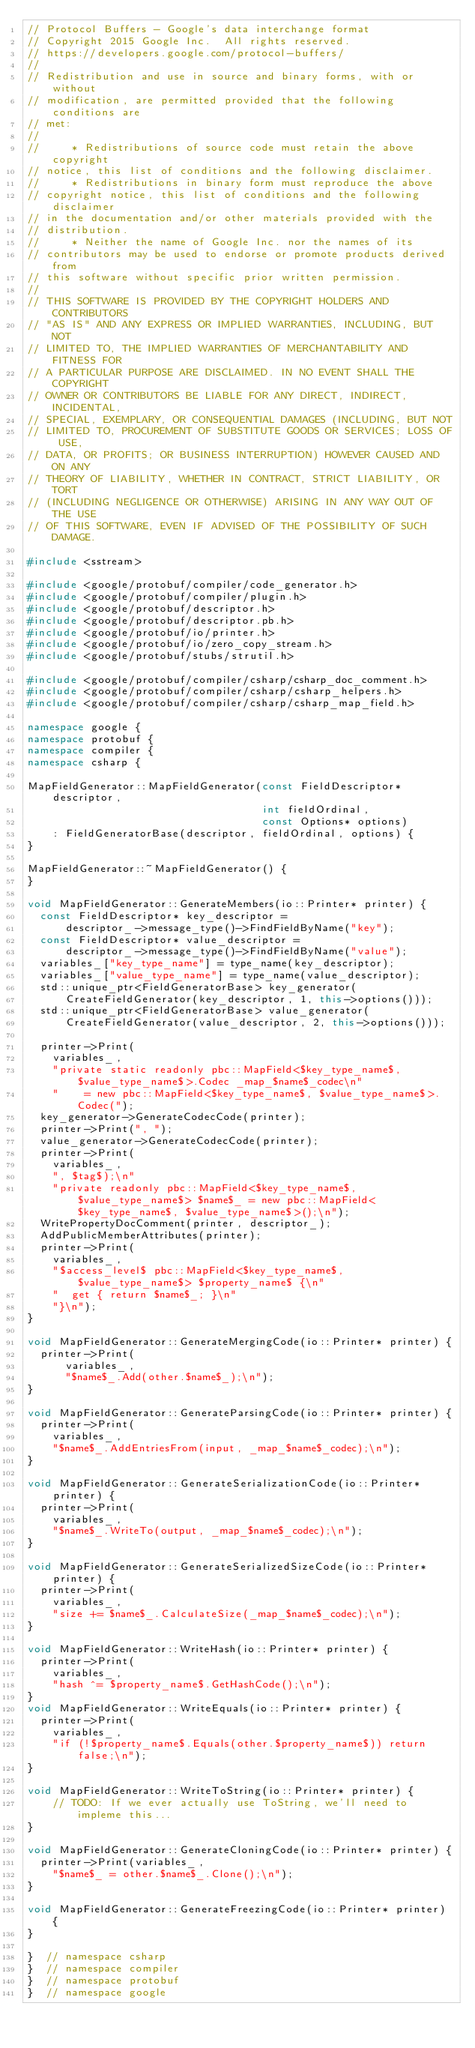Convert code to text. <code><loc_0><loc_0><loc_500><loc_500><_C++_>// Protocol Buffers - Google's data interchange format
// Copyright 2015 Google Inc.  All rights reserved.
// https://developers.google.com/protocol-buffers/
//
// Redistribution and use in source and binary forms, with or without
// modification, are permitted provided that the following conditions are
// met:
//
//     * Redistributions of source code must retain the above copyright
// notice, this list of conditions and the following disclaimer.
//     * Redistributions in binary form must reproduce the above
// copyright notice, this list of conditions and the following disclaimer
// in the documentation and/or other materials provided with the
// distribution.
//     * Neither the name of Google Inc. nor the names of its
// contributors may be used to endorse or promote products derived from
// this software without specific prior written permission.
//
// THIS SOFTWARE IS PROVIDED BY THE COPYRIGHT HOLDERS AND CONTRIBUTORS
// "AS IS" AND ANY EXPRESS OR IMPLIED WARRANTIES, INCLUDING, BUT NOT
// LIMITED TO, THE IMPLIED WARRANTIES OF MERCHANTABILITY AND FITNESS FOR
// A PARTICULAR PURPOSE ARE DISCLAIMED. IN NO EVENT SHALL THE COPYRIGHT
// OWNER OR CONTRIBUTORS BE LIABLE FOR ANY DIRECT, INDIRECT, INCIDENTAL,
// SPECIAL, EXEMPLARY, OR CONSEQUENTIAL DAMAGES (INCLUDING, BUT NOT
// LIMITED TO, PROCUREMENT OF SUBSTITUTE GOODS OR SERVICES; LOSS OF USE,
// DATA, OR PROFITS; OR BUSINESS INTERRUPTION) HOWEVER CAUSED AND ON ANY
// THEORY OF LIABILITY, WHETHER IN CONTRACT, STRICT LIABILITY, OR TORT
// (INCLUDING NEGLIGENCE OR OTHERWISE) ARISING IN ANY WAY OUT OF THE USE
// OF THIS SOFTWARE, EVEN IF ADVISED OF THE POSSIBILITY OF SUCH DAMAGE.

#include <sstream>

#include <google/protobuf/compiler/code_generator.h>
#include <google/protobuf/compiler/plugin.h>
#include <google/protobuf/descriptor.h>
#include <google/protobuf/descriptor.pb.h>
#include <google/protobuf/io/printer.h>
#include <google/protobuf/io/zero_copy_stream.h>
#include <google/protobuf/stubs/strutil.h>

#include <google/protobuf/compiler/csharp/csharp_doc_comment.h>
#include <google/protobuf/compiler/csharp/csharp_helpers.h>
#include <google/protobuf/compiler/csharp/csharp_map_field.h>

namespace google {
namespace protobuf {
namespace compiler {
namespace csharp {

MapFieldGenerator::MapFieldGenerator(const FieldDescriptor* descriptor,
                                     int fieldOrdinal,
                                     const Options* options)
    : FieldGeneratorBase(descriptor, fieldOrdinal, options) {
}

MapFieldGenerator::~MapFieldGenerator() {
}

void MapFieldGenerator::GenerateMembers(io::Printer* printer) {   
  const FieldDescriptor* key_descriptor =
      descriptor_->message_type()->FindFieldByName("key");
  const FieldDescriptor* value_descriptor =
      descriptor_->message_type()->FindFieldByName("value");
  variables_["key_type_name"] = type_name(key_descriptor);
  variables_["value_type_name"] = type_name(value_descriptor);
  std::unique_ptr<FieldGeneratorBase> key_generator(
      CreateFieldGenerator(key_descriptor, 1, this->options()));
  std::unique_ptr<FieldGeneratorBase> value_generator(
      CreateFieldGenerator(value_descriptor, 2, this->options()));

  printer->Print(
    variables_,
    "private static readonly pbc::MapField<$key_type_name$, $value_type_name$>.Codec _map_$name$_codec\n"
    "    = new pbc::MapField<$key_type_name$, $value_type_name$>.Codec(");
  key_generator->GenerateCodecCode(printer);
  printer->Print(", ");
  value_generator->GenerateCodecCode(printer);
  printer->Print(
    variables_,
    ", $tag$);\n"
    "private readonly pbc::MapField<$key_type_name$, $value_type_name$> $name$_ = new pbc::MapField<$key_type_name$, $value_type_name$>();\n");
  WritePropertyDocComment(printer, descriptor_);
  AddPublicMemberAttributes(printer);
  printer->Print(
    variables_,
    "$access_level$ pbc::MapField<$key_type_name$, $value_type_name$> $property_name$ {\n"
    "  get { return $name$_; }\n"
    "}\n");
}

void MapFieldGenerator::GenerateMergingCode(io::Printer* printer) {
  printer->Print(
      variables_,
      "$name$_.Add(other.$name$_);\n");
}

void MapFieldGenerator::GenerateParsingCode(io::Printer* printer) {
  printer->Print(
    variables_,
    "$name$_.AddEntriesFrom(input, _map_$name$_codec);\n");
}

void MapFieldGenerator::GenerateSerializationCode(io::Printer* printer) {
  printer->Print(
    variables_,
    "$name$_.WriteTo(output, _map_$name$_codec);\n");
}

void MapFieldGenerator::GenerateSerializedSizeCode(io::Printer* printer) {
  printer->Print(
    variables_,
    "size += $name$_.CalculateSize(_map_$name$_codec);\n");
}

void MapFieldGenerator::WriteHash(io::Printer* printer) {
  printer->Print(
    variables_,
    "hash ^= $property_name$.GetHashCode();\n");
}
void MapFieldGenerator::WriteEquals(io::Printer* printer) {
  printer->Print(
    variables_,
    "if (!$property_name$.Equals(other.$property_name$)) return false;\n");
}

void MapFieldGenerator::WriteToString(io::Printer* printer) {
    // TODO: If we ever actually use ToString, we'll need to impleme this...
}

void MapFieldGenerator::GenerateCloningCode(io::Printer* printer) {
  printer->Print(variables_,
    "$name$_ = other.$name$_.Clone();\n");
}

void MapFieldGenerator::GenerateFreezingCode(io::Printer* printer) {
}

}  // namespace csharp
}  // namespace compiler
}  // namespace protobuf
}  // namespace google
</code> 